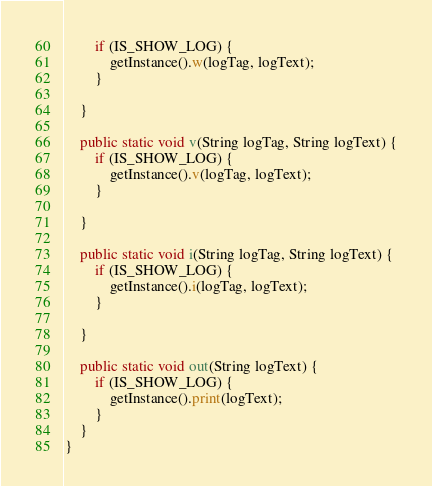<code> <loc_0><loc_0><loc_500><loc_500><_Java_>		if (IS_SHOW_LOG) {
			getInstance().w(logTag, logText);
		}

	}

	public static void v(String logTag, String logText) {
		if (IS_SHOW_LOG) {
			getInstance().v(logTag, logText);
		}

	}

	public static void i(String logTag, String logText) {
		if (IS_SHOW_LOG) {
			getInstance().i(logTag, logText);
		}

	}

	public static void out(String logText) {
		if (IS_SHOW_LOG) {
			getInstance().print(logText);
		}
	}
}
</code> 